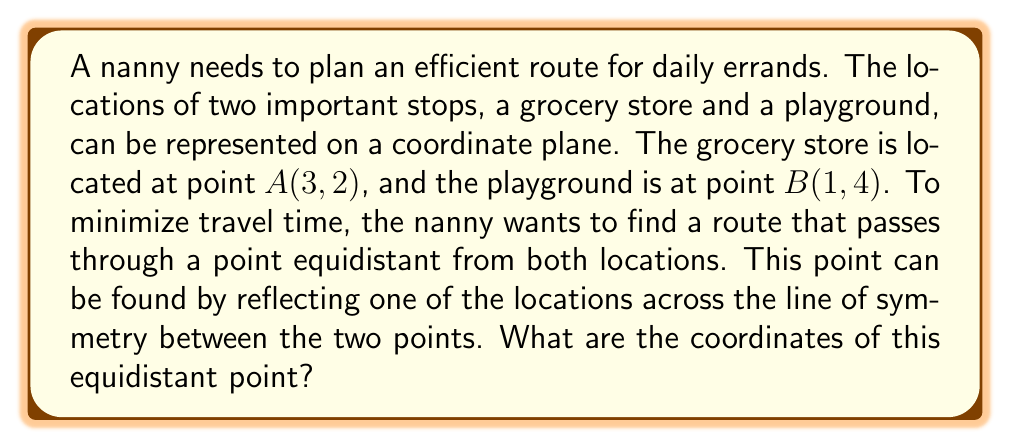Show me your answer to this math problem. 1. To find the line of symmetry, we need to calculate the midpoint between $A(3, 2)$ and $B(1, 4)$:
   Midpoint = $(\frac{x_1 + x_2}{2}, \frac{y_1 + y_2}{2}) = (\frac{3 + 1}{2}, \frac{2 + 4}{2}) = (2, 3)$

2. The line of symmetry passes through this midpoint $(2, 3)$ and is perpendicular to the line segment $\overline{AB}$.

3. To find the equidistant point, we can reflect point $A$ across the line of symmetry. This is equivalent to finding the point that is as far from the midpoint as $A$ is, but in the opposite direction.

4. Calculate the vector from $A$ to the midpoint:
   $\vec{v} = (2 - 3, 3 - 2) = (-1, 1)$

5. Double this vector and add it to the coordinates of $A$ to get the reflected point:
   Reflected point = $(3 + 2(-1), 2 + 2(1)) = (3 - 2, 2 + 2) = (1, 4)$

6. The reflected point $(1, 4)$ is equidistant from both $A$ and $B$, and represents the optimal location for the nanny to pass through on her route.
Answer: $(1, 4)$ 